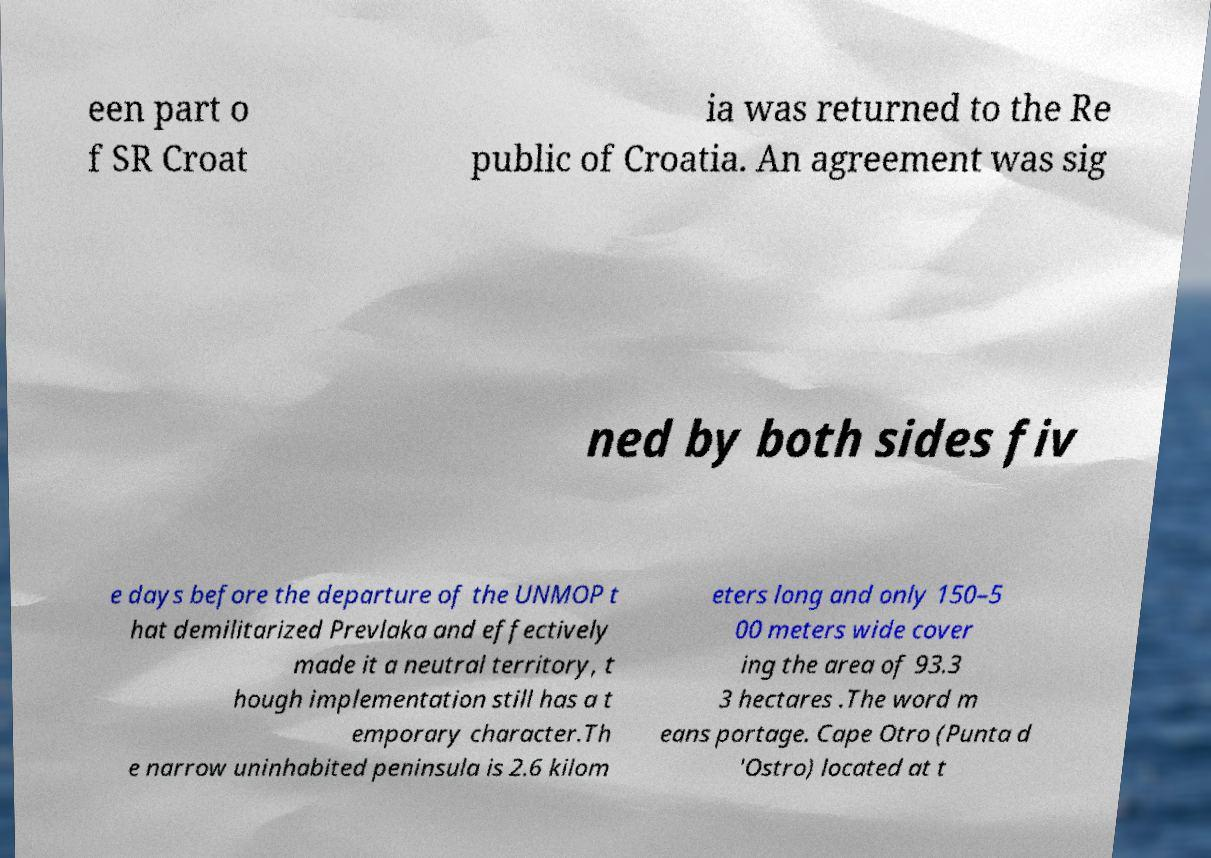There's text embedded in this image that I need extracted. Can you transcribe it verbatim? een part o f SR Croat ia was returned to the Re public of Croatia. An agreement was sig ned by both sides fiv e days before the departure of the UNMOP t hat demilitarized Prevlaka and effectively made it a neutral territory, t hough implementation still has a t emporary character.Th e narrow uninhabited peninsula is 2.6 kilom eters long and only 150–5 00 meters wide cover ing the area of 93.3 3 hectares .The word m eans portage. Cape Otro (Punta d 'Ostro) located at t 